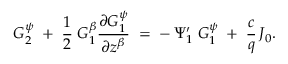Convert formula to latex. <formula><loc_0><loc_0><loc_500><loc_500>G _ { 2 } ^ { \psi } \, + \, \frac { 1 } { 2 } \, G _ { 1 } ^ { \beta } \frac { \partial G _ { 1 } ^ { \psi } } { \partial z ^ { \beta } } \, = \, - \, \Psi _ { 1 } ^ { \prime } \, G _ { 1 } ^ { \psi } \, + \, \frac { c } { q } \, J _ { 0 } .</formula> 